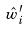<formula> <loc_0><loc_0><loc_500><loc_500>\hat { w } _ { i } ^ { \prime }</formula> 